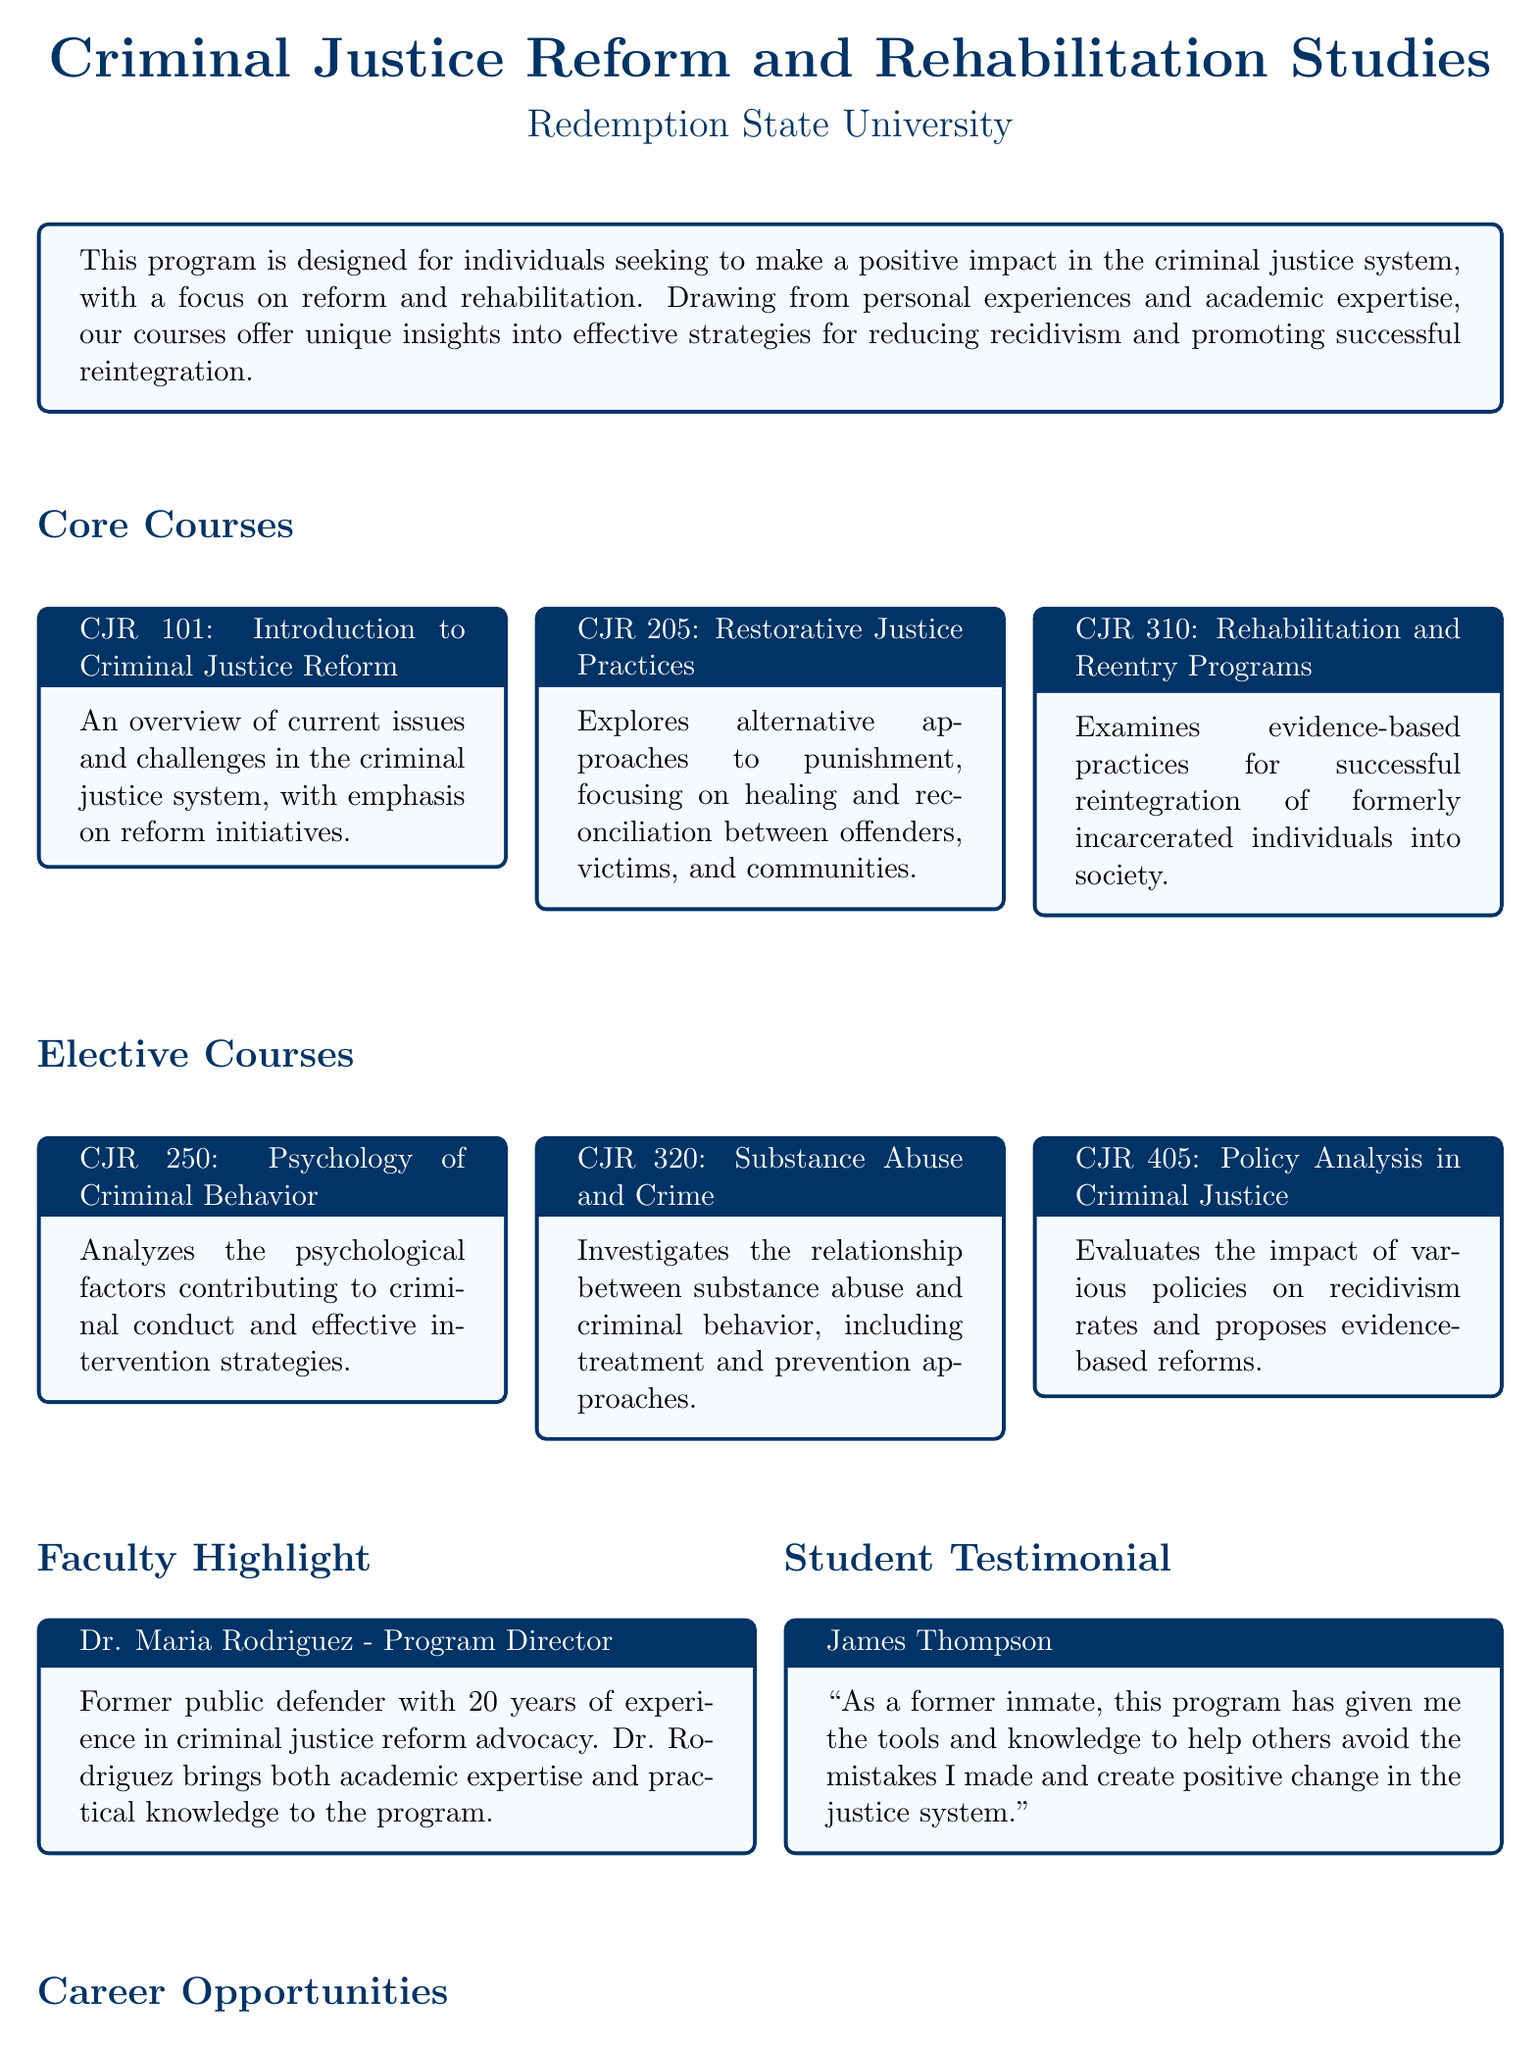What is the name of the university offering the program? The name of the university is mentioned at the beginning of the document under the title.
Answer: Redemption State University How many core courses are listed in the document? The document outlines the number of core courses in the section titled "Core Courses."
Answer: Three What is the course code for "Restorative Justice Practices"? The course code for "Restorative Justice Practices" can be found in the core courses section.
Answer: CJR 205 Who is the Program Director mentioned in the faculty highlight? The name of the Program Director is provided in the faculty highlight section.
Answer: Dr. Maria Rodriguez What type of job can one pursue as a Rehabilitation Counselor? The document lists potential career opportunities under the "Career Opportunities" section.
Answer: Rehabilitation Counselor What is the focus of the course "Psychology of Criminal Behavior"? The focus of the course is detailed in the elective courses section.
Answer: Psychological factors contributing to criminal conduct What is the primary goal of the program? The primary goal of the program is described in the introductory box at the beginning.
Answer: Make a positive impact in the criminal justice system What kind of approaches does the "Substance Abuse and Crime" course investigate? The type of approaches covered in the course can be found in the description of that elective course.
Answer: Treatment and prevention approaches 